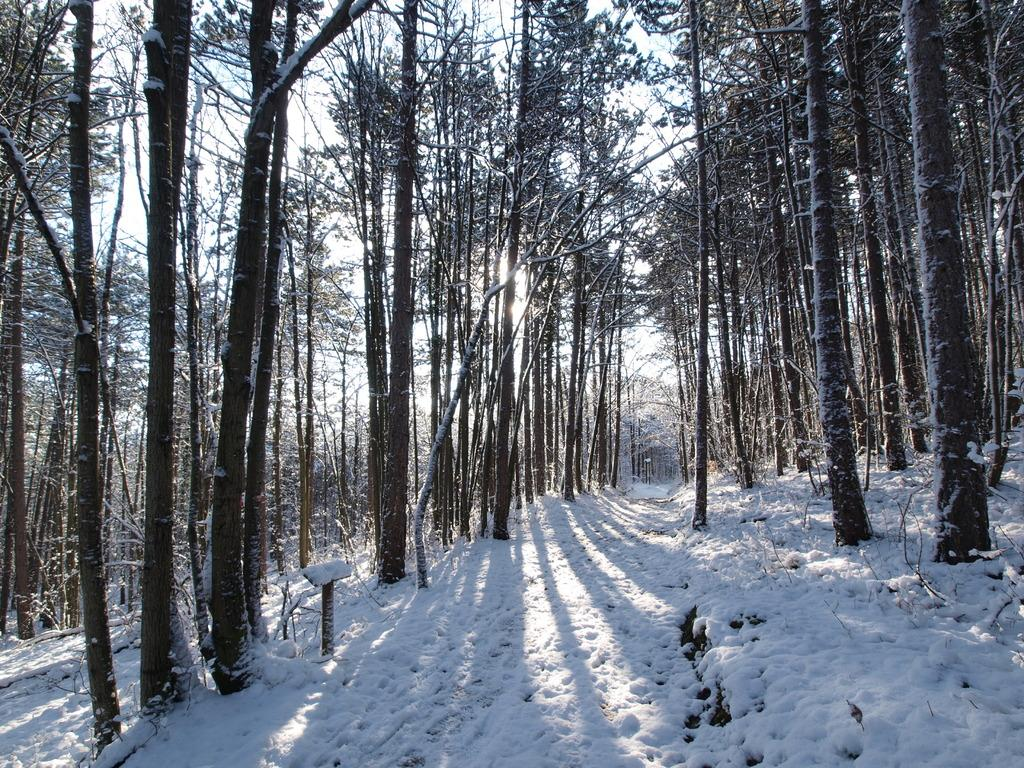What is covering the ground in the center of the image? There is snow on the ground in the center of the image. What can be seen in the distance in the image? There are trees in the background of the image. What type of roll can be seen in the image? There is no roll present in the image. 